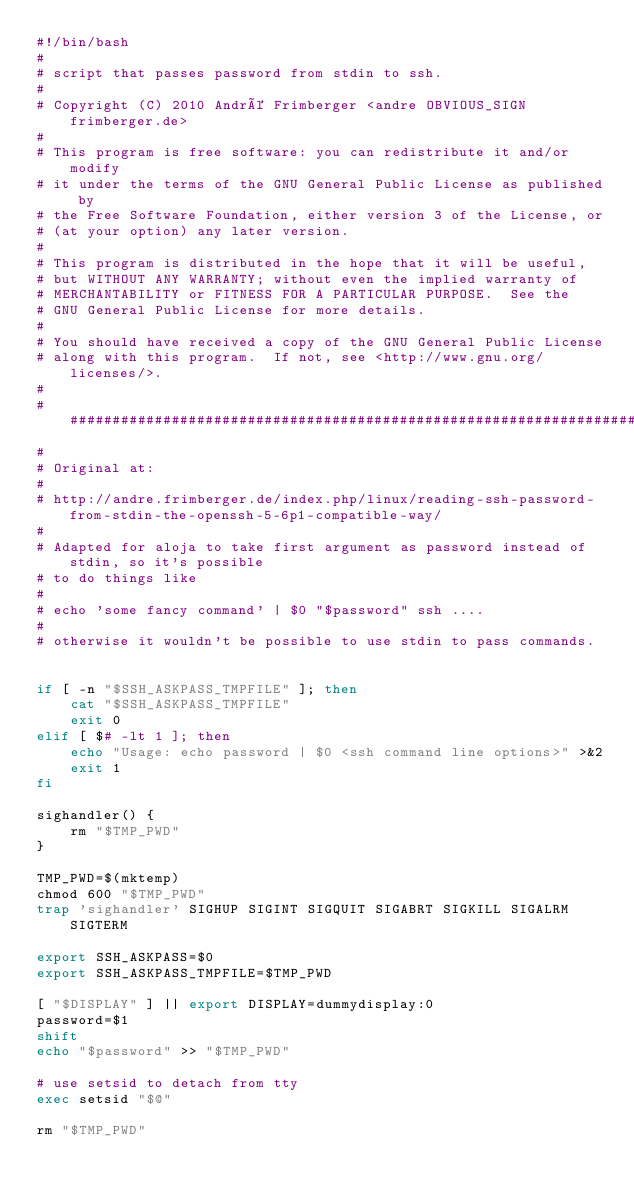Convert code to text. <code><loc_0><loc_0><loc_500><loc_500><_Bash_>#!/bin/bash
# 
# script that passes password from stdin to ssh. 
# 
# Copyright (C) 2010 André Frimberger <andre OBVIOUS_SIGN frimberger.de>
#
# This program is free software: you can redistribute it and/or modify
# it under the terms of the GNU General Public License as published by
# the Free Software Foundation, either version 3 of the License, or 
# (at your option) any later version.
#
# This program is distributed in the hope that it will be useful,
# but WITHOUT ANY WARRANTY; without even the implied warranty of
# MERCHANTABILITY or FITNESS FOR A PARTICULAR PURPOSE.  See the
# GNU General Public License for more details.
#
# You should have received a copy of the GNU General Public License
# along with this program.  If not, see <http://www.gnu.org/licenses/>.
#
########################################################################
#
# Original at:
#
# http://andre.frimberger.de/index.php/linux/reading-ssh-password-from-stdin-the-openssh-5-6p1-compatible-way/
#
# Adapted for aloja to take first argument as password instead of stdin, so it's possible
# to do things like 
#
# echo 'some fancy command' | $0 "$password" ssh ....
#
# otherwise it wouldn't be possible to use stdin to pass commands.

 
if [ -n "$SSH_ASKPASS_TMPFILE" ]; then
    cat "$SSH_ASKPASS_TMPFILE"
    exit 0
elif [ $# -lt 1 ]; then
    echo "Usage: echo password | $0 <ssh command line options>" >&2
    exit 1
fi
 
sighandler() {
    rm "$TMP_PWD"
}
 
TMP_PWD=$(mktemp)
chmod 600 "$TMP_PWD"
trap 'sighandler' SIGHUP SIGINT SIGQUIT SIGABRT SIGKILL SIGALRM SIGTERM
 
export SSH_ASKPASS=$0
export SSH_ASKPASS_TMPFILE=$TMP_PWD
 
[ "$DISPLAY" ] || export DISPLAY=dummydisplay:0
password=$1
shift
echo "$password" >> "$TMP_PWD"
 
# use setsid to detach from tty
exec setsid "$@"
 
rm "$TMP_PWD"
</code> 